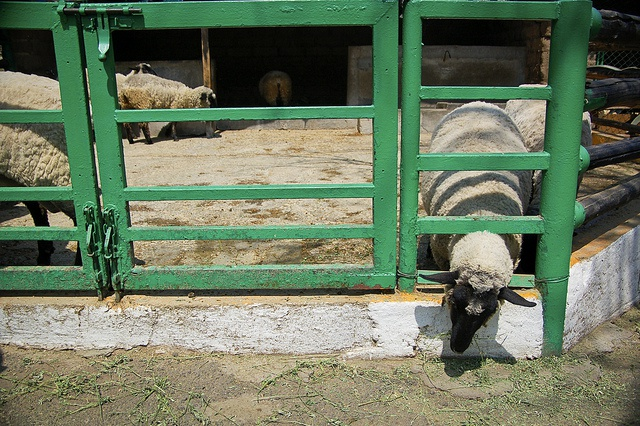Describe the objects in this image and their specific colors. I can see sheep in black, gray, darkgray, and lightgray tones, sheep in black and tan tones, sheep in black, tan, and green tones, sheep in black, darkgray, lightgray, and gray tones, and sheep in black tones in this image. 